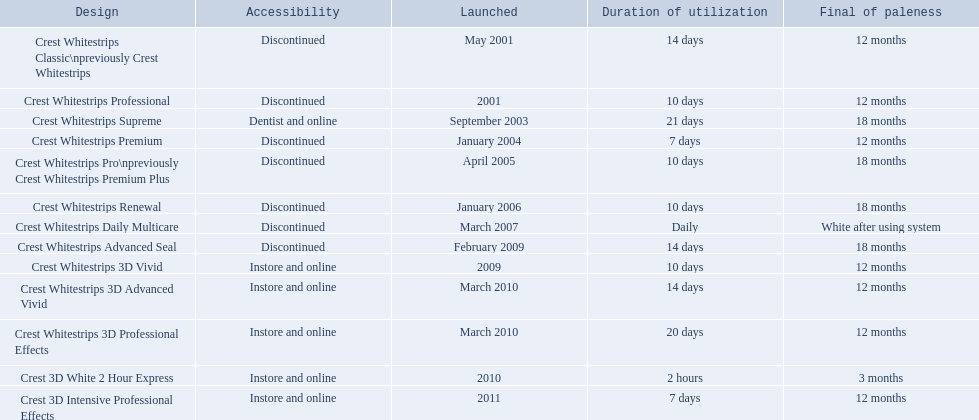What are all the models? Crest Whitestrips Classic\npreviously Crest Whitestrips, Crest Whitestrips Professional, Crest Whitestrips Supreme, Crest Whitestrips Premium, Crest Whitestrips Pro\npreviously Crest Whitestrips Premium Plus, Crest Whitestrips Renewal, Crest Whitestrips Daily Multicare, Crest Whitestrips Advanced Seal, Crest Whitestrips 3D Vivid, Crest Whitestrips 3D Advanced Vivid, Crest Whitestrips 3D Professional Effects, Crest 3D White 2 Hour Express, Crest 3D Intensive Professional Effects. Of these, for which can a ratio be calculated for 'length of use' to 'last of whiteness'? Crest Whitestrips Classic\npreviously Crest Whitestrips, Crest Whitestrips Professional, Crest Whitestrips Supreme, Crest Whitestrips Premium, Crest Whitestrips Pro\npreviously Crest Whitestrips Premium Plus, Crest Whitestrips Renewal, Crest Whitestrips Advanced Seal, Crest Whitestrips 3D Vivid, Crest Whitestrips 3D Advanced Vivid, Crest Whitestrips 3D Professional Effects, Crest 3D White 2 Hour Express, Crest 3D Intensive Professional Effects. Which has the highest ratio? Crest Whitestrips Supreme. 